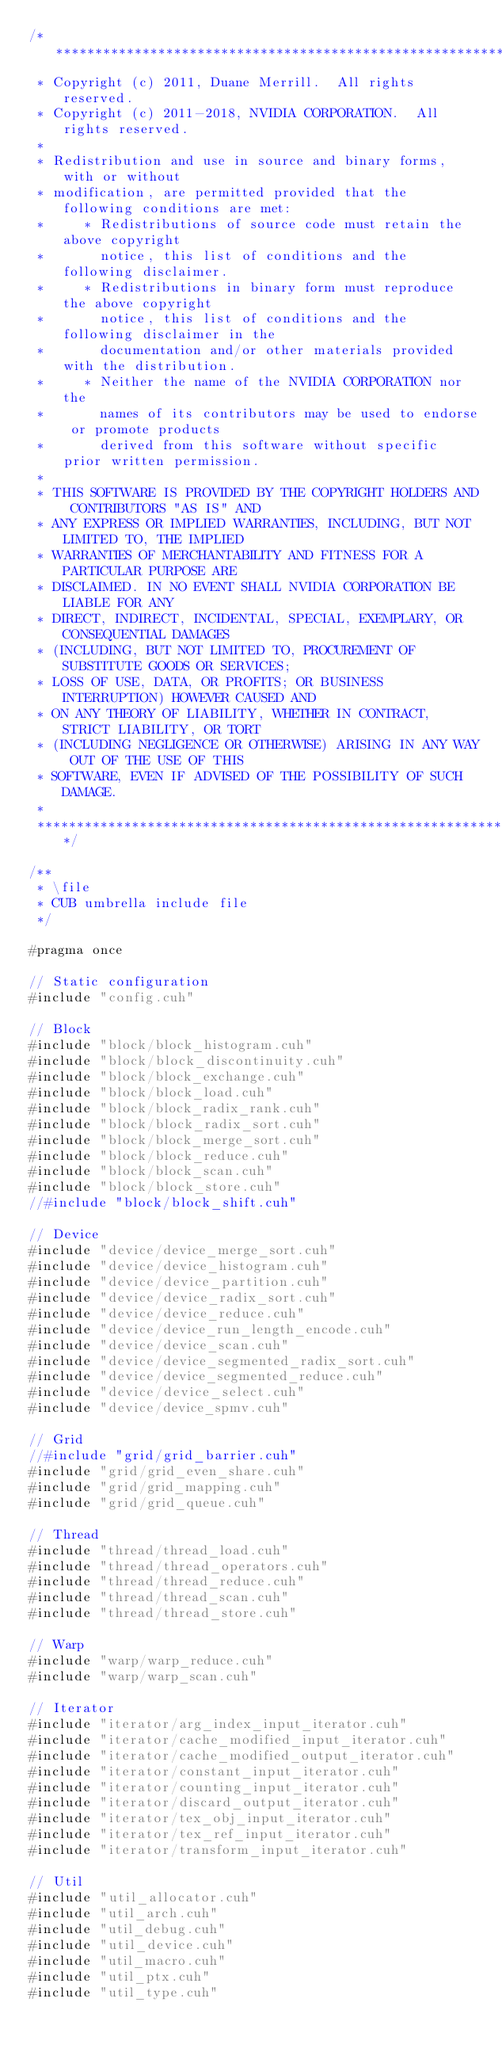Convert code to text. <code><loc_0><loc_0><loc_500><loc_500><_Cuda_>/******************************************************************************
 * Copyright (c) 2011, Duane Merrill.  All rights reserved.
 * Copyright (c) 2011-2018, NVIDIA CORPORATION.  All rights reserved.
 * 
 * Redistribution and use in source and binary forms, with or without
 * modification, are permitted provided that the following conditions are met:
 *     * Redistributions of source code must retain the above copyright
 *       notice, this list of conditions and the following disclaimer.
 *     * Redistributions in binary form must reproduce the above copyright
 *       notice, this list of conditions and the following disclaimer in the
 *       documentation and/or other materials provided with the distribution.
 *     * Neither the name of the NVIDIA CORPORATION nor the
 *       names of its contributors may be used to endorse or promote products
 *       derived from this software without specific prior written permission.
 * 
 * THIS SOFTWARE IS PROVIDED BY THE COPYRIGHT HOLDERS AND CONTRIBUTORS "AS IS" AND
 * ANY EXPRESS OR IMPLIED WARRANTIES, INCLUDING, BUT NOT LIMITED TO, THE IMPLIED
 * WARRANTIES OF MERCHANTABILITY AND FITNESS FOR A PARTICULAR PURPOSE ARE
 * DISCLAIMED. IN NO EVENT SHALL NVIDIA CORPORATION BE LIABLE FOR ANY
 * DIRECT, INDIRECT, INCIDENTAL, SPECIAL, EXEMPLARY, OR CONSEQUENTIAL DAMAGES
 * (INCLUDING, BUT NOT LIMITED TO, PROCUREMENT OF SUBSTITUTE GOODS OR SERVICES;
 * LOSS OF USE, DATA, OR PROFITS; OR BUSINESS INTERRUPTION) HOWEVER CAUSED AND
 * ON ANY THEORY OF LIABILITY, WHETHER IN CONTRACT, STRICT LIABILITY, OR TORT
 * (INCLUDING NEGLIGENCE OR OTHERWISE) ARISING IN ANY WAY OUT OF THE USE OF THIS
 * SOFTWARE, EVEN IF ADVISED OF THE POSSIBILITY OF SUCH DAMAGE.
 *
 ******************************************************************************/

/**
 * \file
 * CUB umbrella include file
 */

#pragma once

// Static configuration
#include "config.cuh"

// Block
#include "block/block_histogram.cuh"
#include "block/block_discontinuity.cuh"
#include "block/block_exchange.cuh"
#include "block/block_load.cuh"
#include "block/block_radix_rank.cuh"
#include "block/block_radix_sort.cuh"
#include "block/block_merge_sort.cuh"
#include "block/block_reduce.cuh"
#include "block/block_scan.cuh"
#include "block/block_store.cuh"
//#include "block/block_shift.cuh"

// Device
#include "device/device_merge_sort.cuh"
#include "device/device_histogram.cuh"
#include "device/device_partition.cuh"
#include "device/device_radix_sort.cuh"
#include "device/device_reduce.cuh"
#include "device/device_run_length_encode.cuh"
#include "device/device_scan.cuh"
#include "device/device_segmented_radix_sort.cuh"
#include "device/device_segmented_reduce.cuh"
#include "device/device_select.cuh"
#include "device/device_spmv.cuh"

// Grid
//#include "grid/grid_barrier.cuh"
#include "grid/grid_even_share.cuh"
#include "grid/grid_mapping.cuh"
#include "grid/grid_queue.cuh"

// Thread
#include "thread/thread_load.cuh"
#include "thread/thread_operators.cuh"
#include "thread/thread_reduce.cuh"
#include "thread/thread_scan.cuh"
#include "thread/thread_store.cuh"

// Warp
#include "warp/warp_reduce.cuh"
#include "warp/warp_scan.cuh"

// Iterator
#include "iterator/arg_index_input_iterator.cuh"
#include "iterator/cache_modified_input_iterator.cuh"
#include "iterator/cache_modified_output_iterator.cuh"
#include "iterator/constant_input_iterator.cuh"
#include "iterator/counting_input_iterator.cuh"
#include "iterator/discard_output_iterator.cuh"
#include "iterator/tex_obj_input_iterator.cuh"
#include "iterator/tex_ref_input_iterator.cuh"
#include "iterator/transform_input_iterator.cuh"

// Util
#include "util_allocator.cuh"
#include "util_arch.cuh"
#include "util_debug.cuh"
#include "util_device.cuh"
#include "util_macro.cuh"
#include "util_ptx.cuh"
#include "util_type.cuh"

</code> 